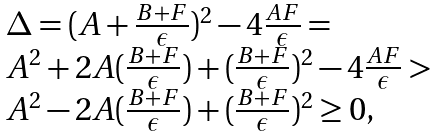Convert formula to latex. <formula><loc_0><loc_0><loc_500><loc_500>\begin{array} { l } \Delta = ( A + \frac { B + F } { \epsilon } ) ^ { 2 } - 4 \frac { A F } { \epsilon } = \\ A ^ { 2 } + 2 A ( \frac { B + F } { \epsilon } ) + ( \frac { B + F } { \epsilon } ) ^ { 2 } - 4 \frac { A F } { \epsilon } > \\ A ^ { 2 } - 2 A ( \frac { B + F } { \epsilon } ) + ( \frac { B + F } { \epsilon } ) ^ { 2 } \geq 0 , \\ \end{array}</formula> 